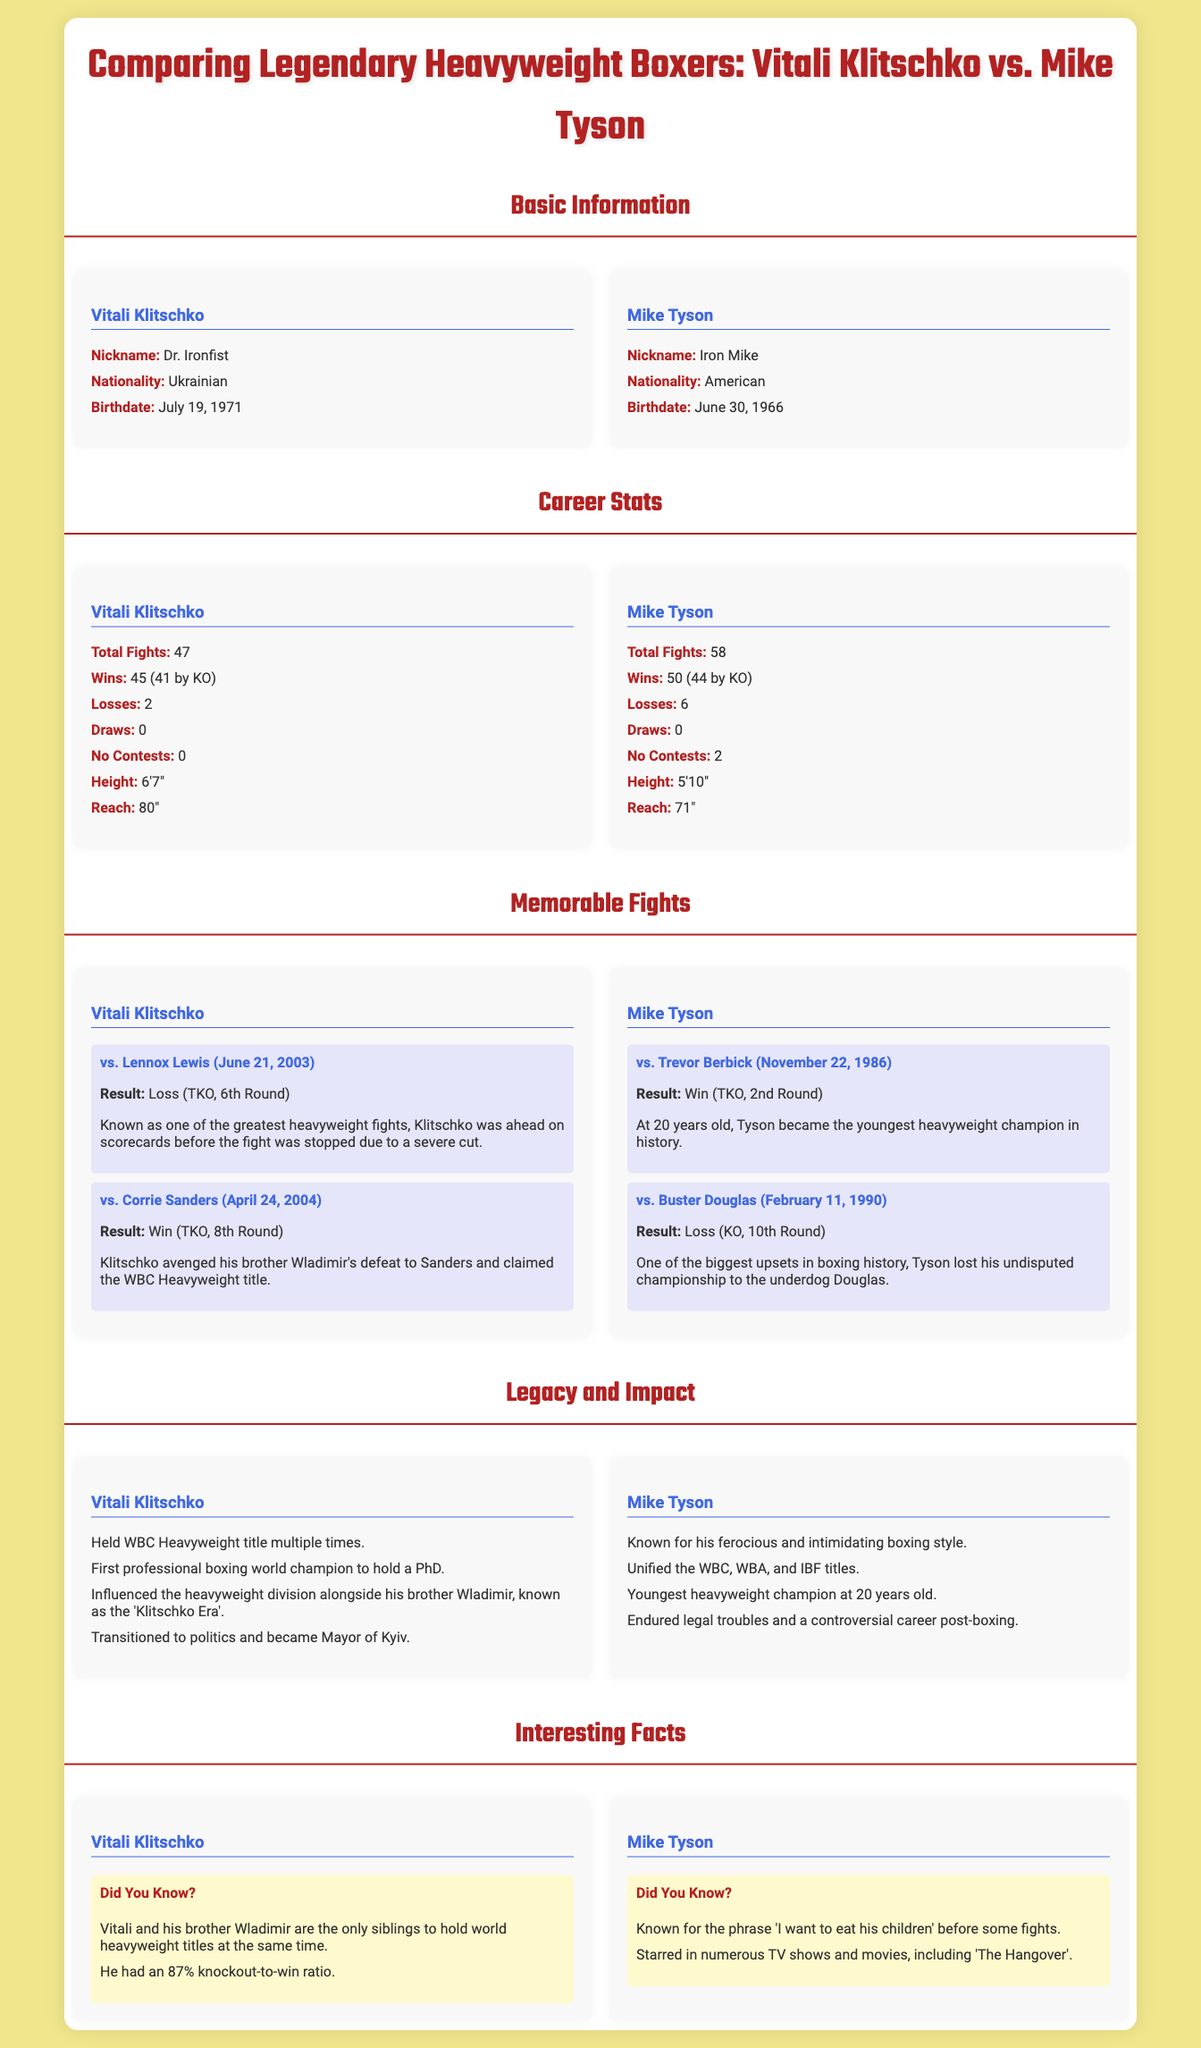What is Vitali Klitschko's nickname? The nickname listed for Vitali Klitschko in the document is "Dr. Ironfist".
Answer: Dr. Ironfist How many total fights did Mike Tyson have? The document states that Mike Tyson had a total of 58 fights.
Answer: 58 What is the height of Vitali Klitschko? The height of Vitali Klitschko mentioned in the document is 6'7".
Answer: 6'7" How many losses did Vitali Klitschko have? The document indicates that Vitali Klitschko had 2 losses in his career.
Answer: 2 Which boxer became the youngest heavyweight champion? The document details that Mike Tyson became the youngest heavyweight champion at the age of 20.
Answer: 20 What was the result of the fight between Vitali Klitschko and Lennox Lewis? The document states that the fight resulted in a loss for Vitali Klitschko by TKO in the 6th round.
Answer: Loss (TKO, 6th Round) How many KOs did Mike Tyson have in his wins? The document details that Mike Tyson had 44 wins by KO.
Answer: 44 In what year did Mike Tyson fight Buster Douglas? The document notes that the fight with Buster Douglas took place on February 11, 1990.
Answer: February 11, 1990 What did Vitali Klitschko do after boxing? The document mentions that Vitali Klitschko transitioned to politics and became Mayor of Kyiv.
Answer: Mayor of Kyiv 